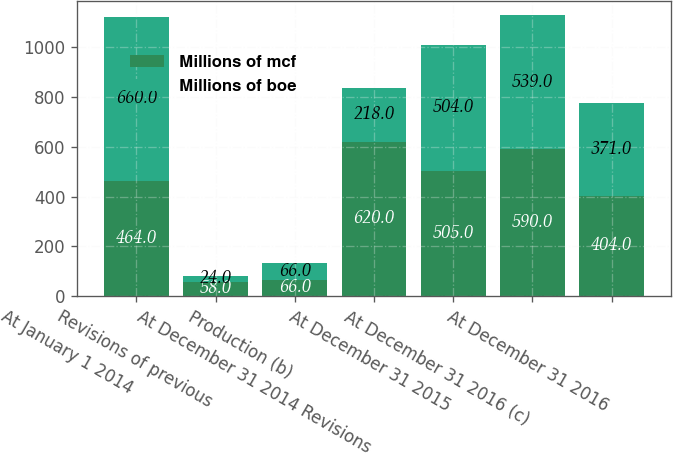<chart> <loc_0><loc_0><loc_500><loc_500><stacked_bar_chart><ecel><fcel>At January 1 2014<fcel>Revisions of previous<fcel>Production (b)<fcel>At December 31 2014 Revisions<fcel>At December 31 2015<fcel>At December 31 2016 (c)<fcel>At December 31 2016<nl><fcel>Millions of mcf<fcel>464<fcel>58<fcel>66<fcel>620<fcel>505<fcel>590<fcel>404<nl><fcel>Millions of boe<fcel>660<fcel>24<fcel>66<fcel>218<fcel>504<fcel>539<fcel>371<nl></chart> 